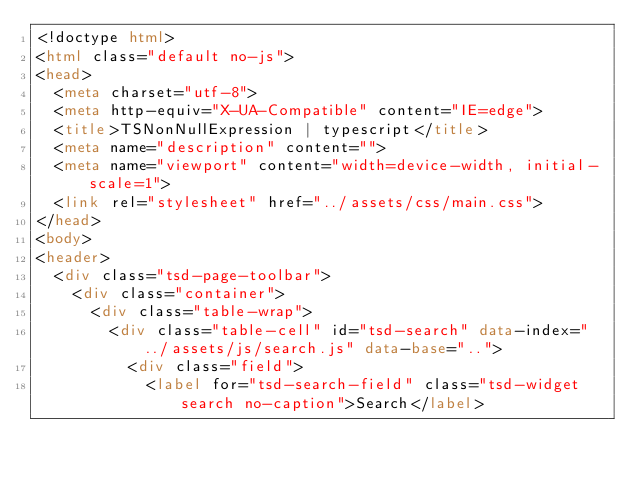Convert code to text. <code><loc_0><loc_0><loc_500><loc_500><_HTML_><!doctype html>
<html class="default no-js">
<head>
	<meta charset="utf-8">
	<meta http-equiv="X-UA-Compatible" content="IE=edge">
	<title>TSNonNullExpression | typescript</title>
	<meta name="description" content="">
	<meta name="viewport" content="width=device-width, initial-scale=1">
	<link rel="stylesheet" href="../assets/css/main.css">
</head>
<body>
<header>
	<div class="tsd-page-toolbar">
		<div class="container">
			<div class="table-wrap">
				<div class="table-cell" id="tsd-search" data-index="../assets/js/search.js" data-base="..">
					<div class="field">
						<label for="tsd-search-field" class="tsd-widget search no-caption">Search</label></code> 